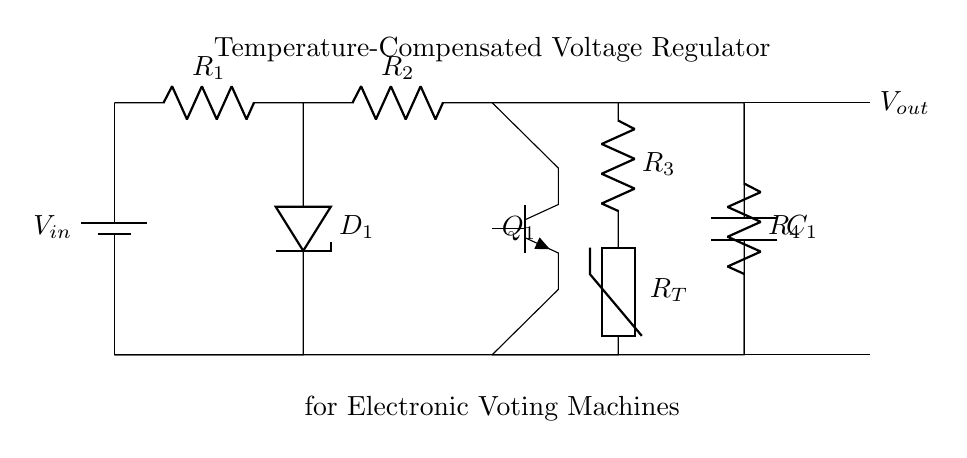What is the purpose of the Zener diode in this circuit? The Zener diode regulates the output voltage by maintaining a constant voltage level across it when it is reverse-biased. This makes it essential for voltage regulation.
Answer: Voltage regulation What does the thermistor do in this circuit? The thermistor provides temperature compensation, meaning its resistance changes with temperature, helping to stabilize the output voltage against fluctuations due to temperature changes.
Answer: Temperature compensation What is the output voltage designation in this regulator? The output voltage is denoted as **Vout**, indicating where the regulated output voltage can be taken from the circuit.
Answer: Vout How many resistors are present in the circuit? There are four resistors in total: R1, R2, R3, and R4, which are used for various functions like biasing and output stabilization within the regulator.
Answer: Four What type of transistor is used in this voltage regulator? The circuit uses an NPN transistor, which is a common choice for switching and amplification in electronic applications, including voltage regulation.
Answer: NPN How does this circuit achieve stability? Stability is achieved through the use of capacitor **C1**, which filters out voltage fluctuations and maintains a steady output voltage under varying load conditions.
Answer: Capacitor 